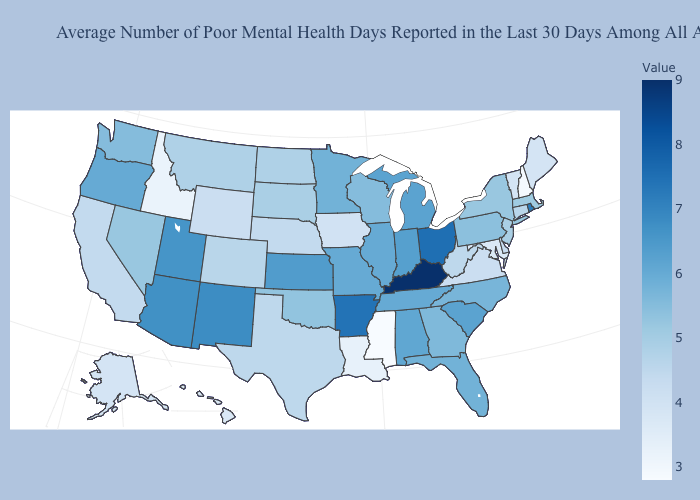Which states hav the highest value in the West?
Concise answer only. New Mexico. Does Kentucky have the highest value in the USA?
Answer briefly. Yes. Which states have the lowest value in the USA?
Quick response, please. Mississippi. Does Kentucky have the highest value in the USA?
Quick response, please. Yes. Does Indiana have the lowest value in the MidWest?
Keep it brief. No. Does New Hampshire have the lowest value in the Northeast?
Quick response, please. Yes. Which states have the highest value in the USA?
Concise answer only. Kentucky. Does Rhode Island have the highest value in the Northeast?
Answer briefly. Yes. Does Mississippi have the lowest value in the USA?
Short answer required. Yes. 